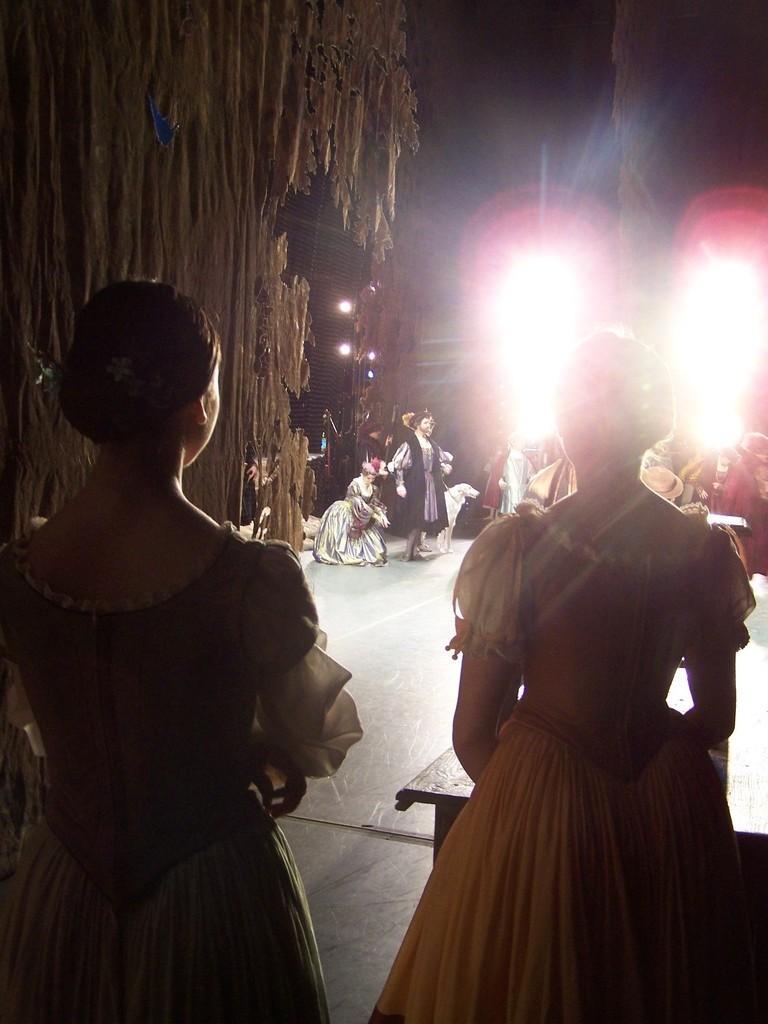In one or two sentences, can you explain what this image depicts? In this image, on the right side, we can see a woman standing in front of the table. On the left side, we can also see another woman standing. In the background, we can see a group of people, lights. On the left side, we can see some trees. On the left side, we can see curtain. In the background, we can see some lights and black color. 